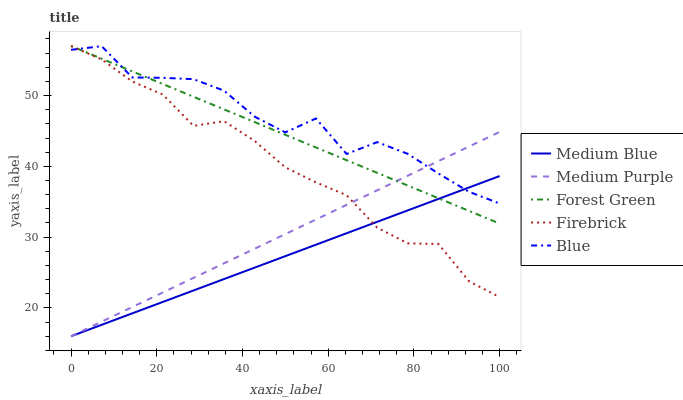Does Medium Blue have the minimum area under the curve?
Answer yes or no. Yes. Does Blue have the maximum area under the curve?
Answer yes or no. Yes. Does Forest Green have the minimum area under the curve?
Answer yes or no. No. Does Forest Green have the maximum area under the curve?
Answer yes or no. No. Is Medium Purple the smoothest?
Answer yes or no. Yes. Is Blue the roughest?
Answer yes or no. Yes. Is Forest Green the smoothest?
Answer yes or no. No. Is Forest Green the roughest?
Answer yes or no. No. Does Medium Purple have the lowest value?
Answer yes or no. Yes. Does Forest Green have the lowest value?
Answer yes or no. No. Does Firebrick have the highest value?
Answer yes or no. Yes. Does Blue have the highest value?
Answer yes or no. No. Does Firebrick intersect Medium Purple?
Answer yes or no. Yes. Is Firebrick less than Medium Purple?
Answer yes or no. No. Is Firebrick greater than Medium Purple?
Answer yes or no. No. 